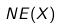<formula> <loc_0><loc_0><loc_500><loc_500>N E ( X )</formula> 